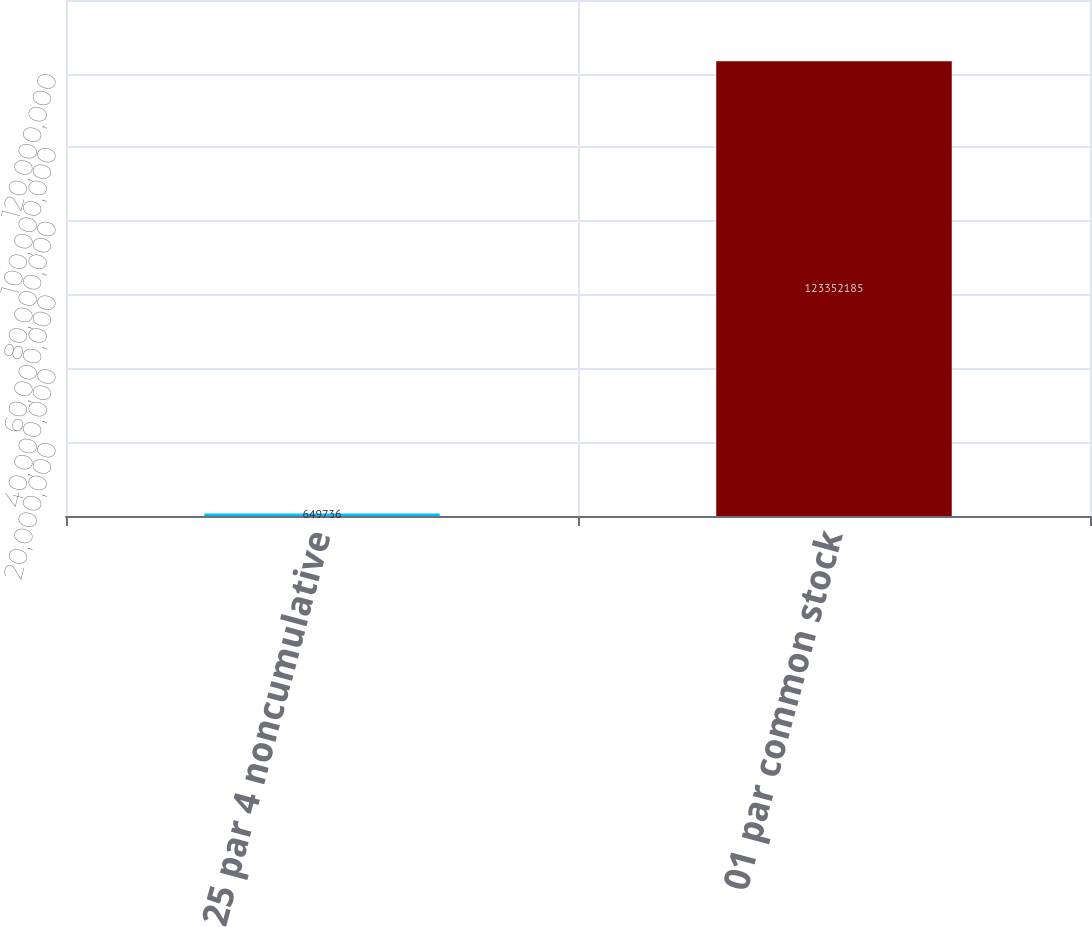<chart> <loc_0><loc_0><loc_500><loc_500><bar_chart><fcel>25 par 4 noncumulative<fcel>01 par common stock<nl><fcel>649736<fcel>1.23352e+08<nl></chart> 